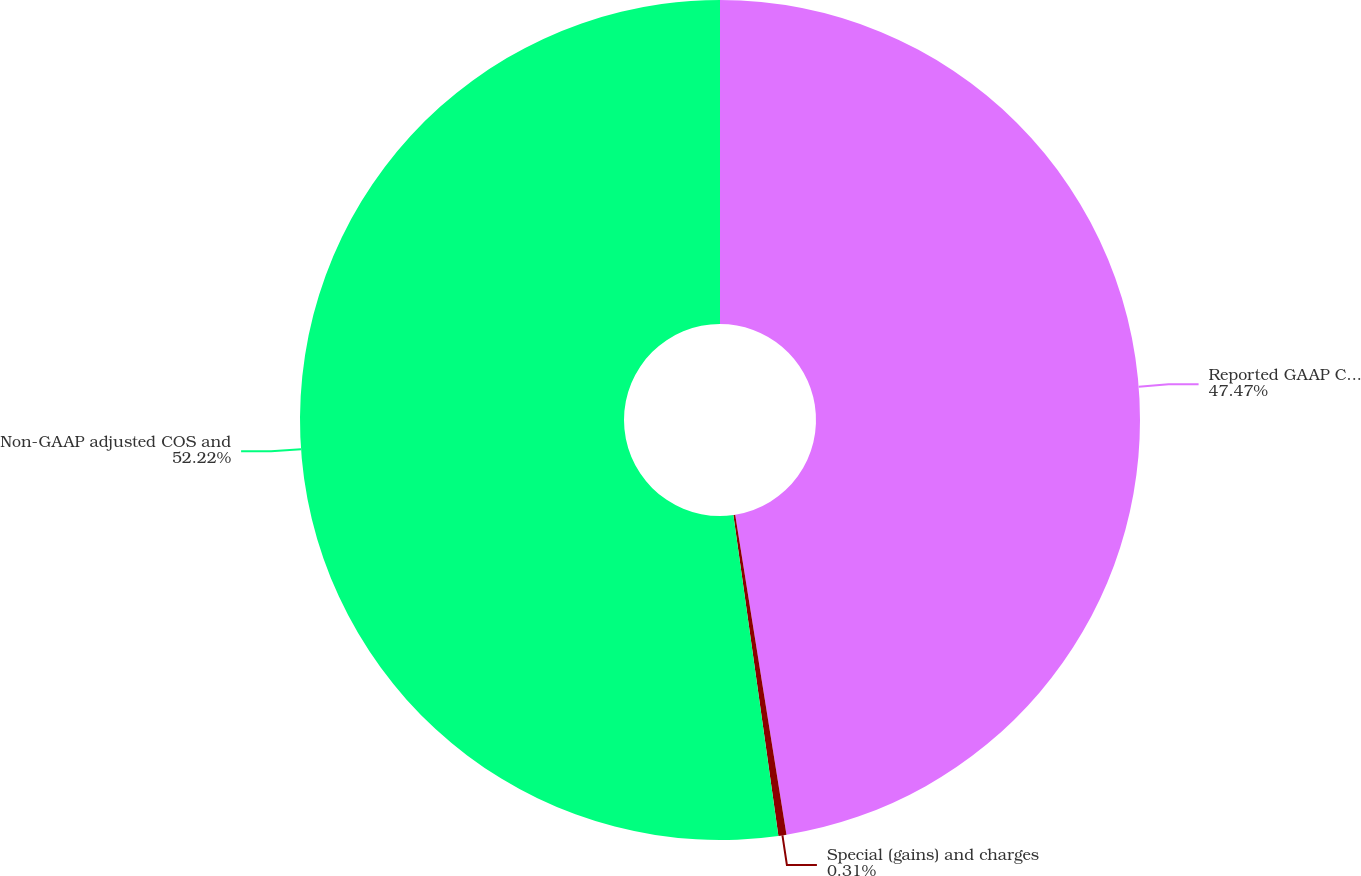Convert chart to OTSL. <chart><loc_0><loc_0><loc_500><loc_500><pie_chart><fcel>Reported GAAP COS and gross<fcel>Special (gains) and charges<fcel>Non-GAAP adjusted COS and<nl><fcel>47.47%<fcel>0.31%<fcel>52.22%<nl></chart> 